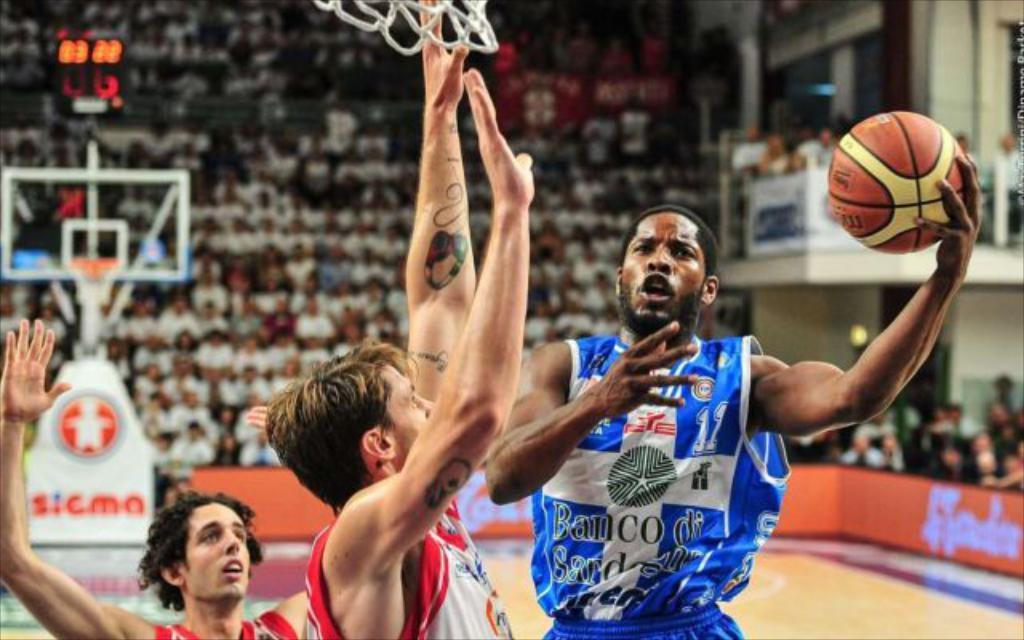Could you give a brief overview of what you see in this image? In the image there is a man with blue jersey holding basket ball in his hand and in front of him there are two other men with red vest keeping their hands up, this is clicked in a basketball stadium, in the back there are many people sitting on chairs and looking at the game and there is goal post on the left side with a scoreboard above it. 